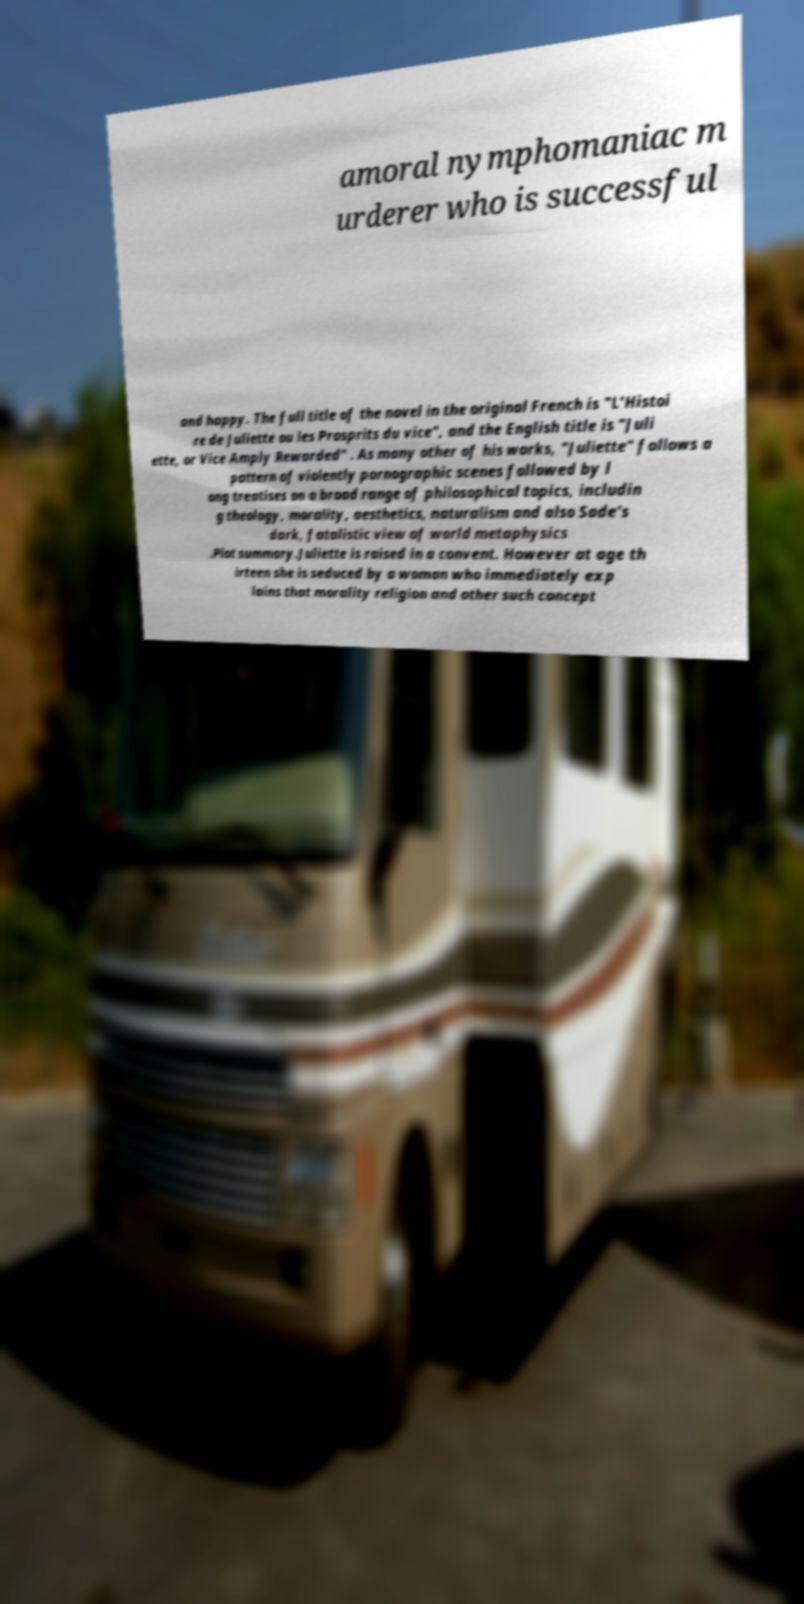What messages or text are displayed in this image? I need them in a readable, typed format. amoral nymphomaniac m urderer who is successful and happy. The full title of the novel in the original French is "L'Histoi re de Juliette ou les Prosprits du vice", and the English title is "Juli ette, or Vice Amply Rewarded" . As many other of his works, "Juliette" follows a pattern of violently pornographic scenes followed by l ong treatises on a broad range of philosophical topics, includin g theology, morality, aesthetics, naturalism and also Sade's dark, fatalistic view of world metaphysics .Plot summary.Juliette is raised in a convent. However at age th irteen she is seduced by a woman who immediately exp lains that morality religion and other such concept 